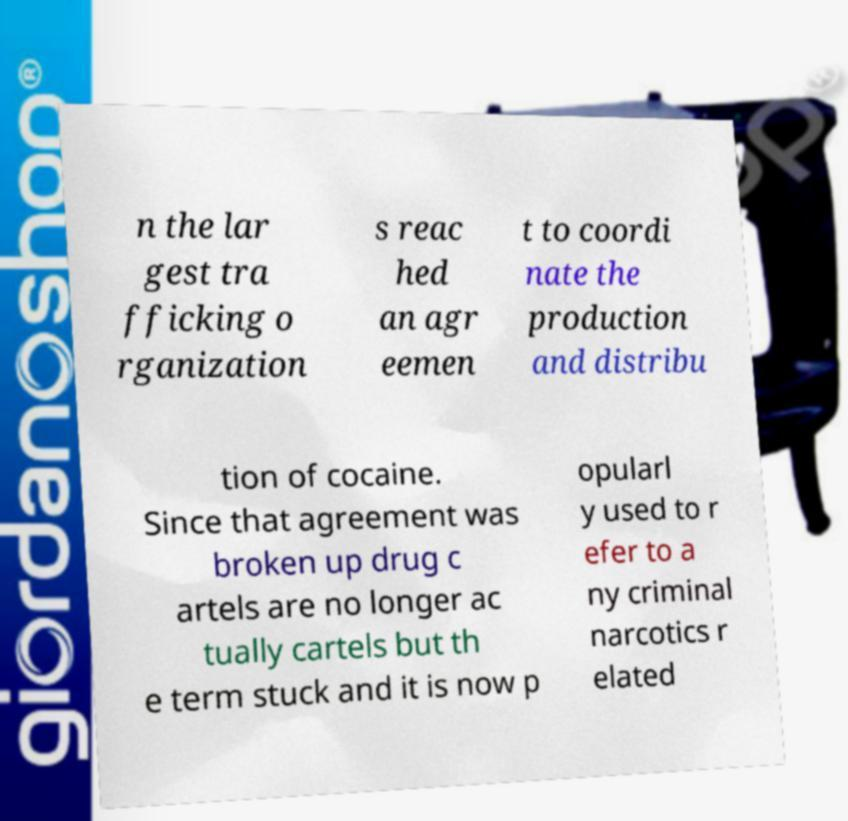Please identify and transcribe the text found in this image. n the lar gest tra fficking o rganization s reac hed an agr eemen t to coordi nate the production and distribu tion of cocaine. Since that agreement was broken up drug c artels are no longer ac tually cartels but th e term stuck and it is now p opularl y used to r efer to a ny criminal narcotics r elated 